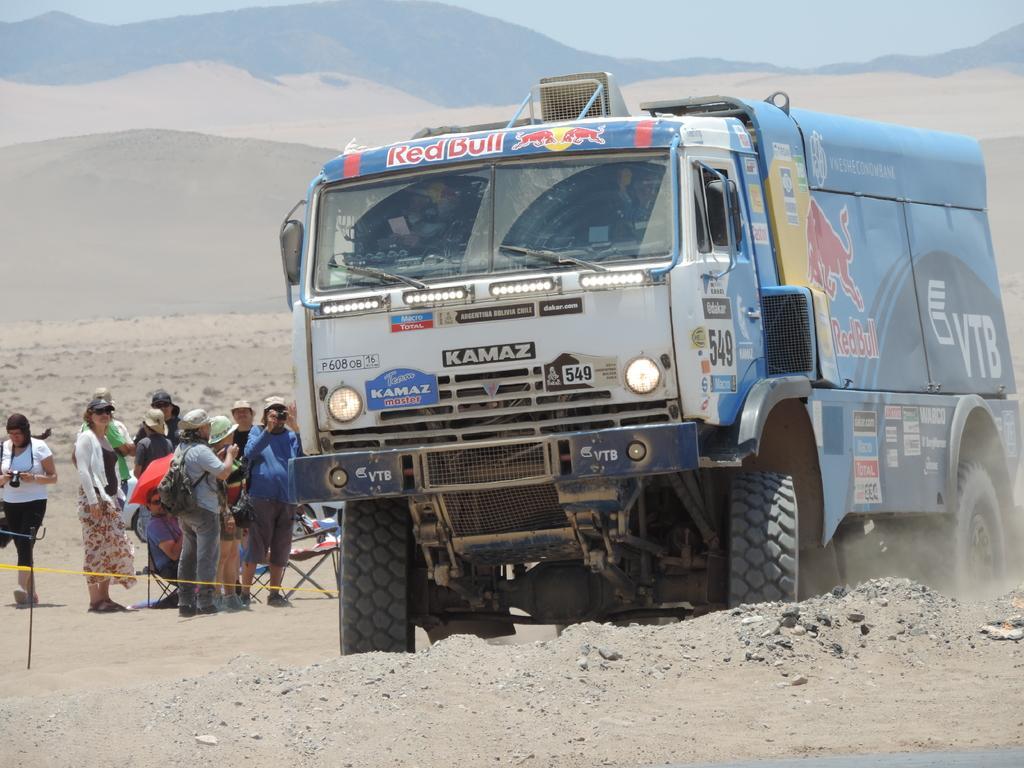Please provide a concise description of this image. In this picture there is a vehicle and there are group of people standing. At the back there are mountains. At the top there is sky. At the bottom there is sand. 